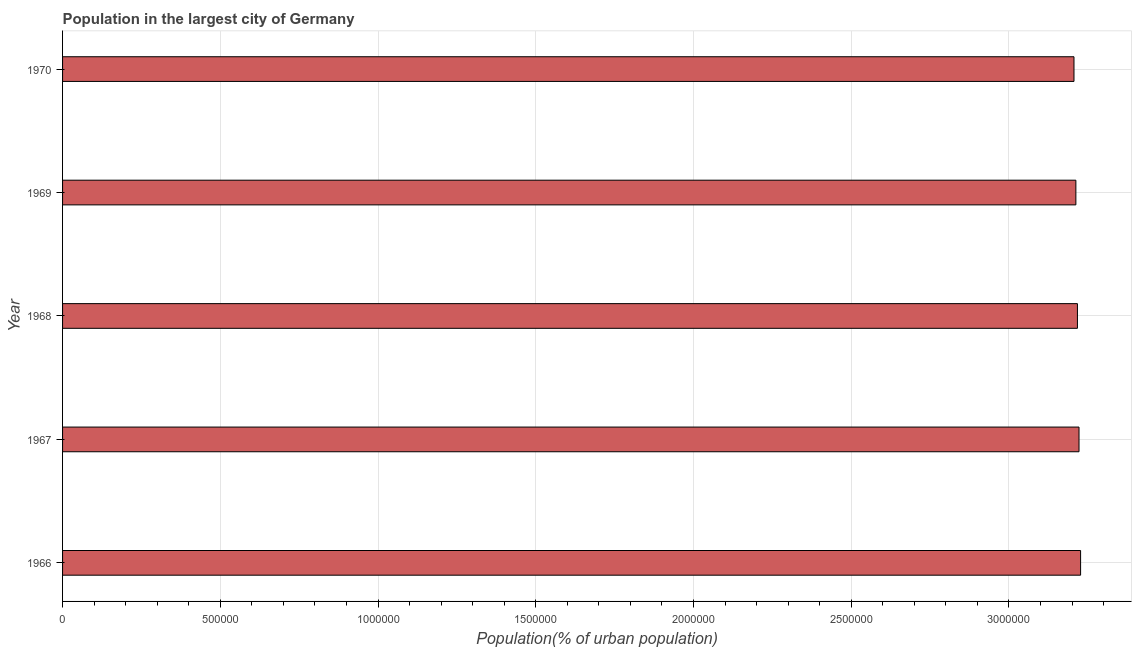Does the graph contain any zero values?
Ensure brevity in your answer.  No. What is the title of the graph?
Provide a succinct answer. Population in the largest city of Germany. What is the label or title of the X-axis?
Ensure brevity in your answer.  Population(% of urban population). What is the population in largest city in 1967?
Make the answer very short. 3.22e+06. Across all years, what is the maximum population in largest city?
Ensure brevity in your answer.  3.23e+06. Across all years, what is the minimum population in largest city?
Provide a short and direct response. 3.21e+06. In which year was the population in largest city maximum?
Offer a very short reply. 1966. In which year was the population in largest city minimum?
Make the answer very short. 1970. What is the sum of the population in largest city?
Make the answer very short. 1.61e+07. What is the difference between the population in largest city in 1966 and 1969?
Provide a succinct answer. 1.50e+04. What is the average population in largest city per year?
Make the answer very short. 3.22e+06. What is the median population in largest city?
Give a very brief answer. 3.22e+06. In how many years, is the population in largest city greater than 1600000 %?
Your answer should be very brief. 5. What is the ratio of the population in largest city in 1966 to that in 1970?
Offer a terse response. 1.01. Is the population in largest city in 1966 less than that in 1970?
Provide a short and direct response. No. Is the difference between the population in largest city in 1966 and 1969 greater than the difference between any two years?
Give a very brief answer. No. What is the difference between the highest and the second highest population in largest city?
Your answer should be compact. 4996. What is the difference between the highest and the lowest population in largest city?
Give a very brief answer. 2.09e+04. In how many years, is the population in largest city greater than the average population in largest city taken over all years?
Your answer should be compact. 3. Are all the bars in the graph horizontal?
Your answer should be very brief. Yes. What is the difference between two consecutive major ticks on the X-axis?
Offer a terse response. 5.00e+05. What is the Population(% of urban population) of 1966?
Your response must be concise. 3.23e+06. What is the Population(% of urban population) in 1967?
Offer a very short reply. 3.22e+06. What is the Population(% of urban population) of 1968?
Make the answer very short. 3.22e+06. What is the Population(% of urban population) of 1969?
Your answer should be compact. 3.21e+06. What is the Population(% of urban population) of 1970?
Your response must be concise. 3.21e+06. What is the difference between the Population(% of urban population) in 1966 and 1967?
Your answer should be very brief. 4996. What is the difference between the Population(% of urban population) in 1966 and 1968?
Your response must be concise. 9992. What is the difference between the Population(% of urban population) in 1966 and 1969?
Provide a short and direct response. 1.50e+04. What is the difference between the Population(% of urban population) in 1966 and 1970?
Provide a succinct answer. 2.09e+04. What is the difference between the Population(% of urban population) in 1967 and 1968?
Provide a short and direct response. 4996. What is the difference between the Population(% of urban population) in 1967 and 1969?
Your answer should be very brief. 9970. What is the difference between the Population(% of urban population) in 1967 and 1970?
Your answer should be very brief. 1.59e+04. What is the difference between the Population(% of urban population) in 1968 and 1969?
Make the answer very short. 4974. What is the difference between the Population(% of urban population) in 1968 and 1970?
Your answer should be compact. 1.09e+04. What is the difference between the Population(% of urban population) in 1969 and 1970?
Give a very brief answer. 5972. What is the ratio of the Population(% of urban population) in 1966 to that in 1967?
Your response must be concise. 1. What is the ratio of the Population(% of urban population) in 1966 to that in 1968?
Ensure brevity in your answer.  1. What is the ratio of the Population(% of urban population) in 1967 to that in 1968?
Ensure brevity in your answer.  1. What is the ratio of the Population(% of urban population) in 1967 to that in 1969?
Your answer should be very brief. 1. What is the ratio of the Population(% of urban population) in 1968 to that in 1969?
Provide a succinct answer. 1. 